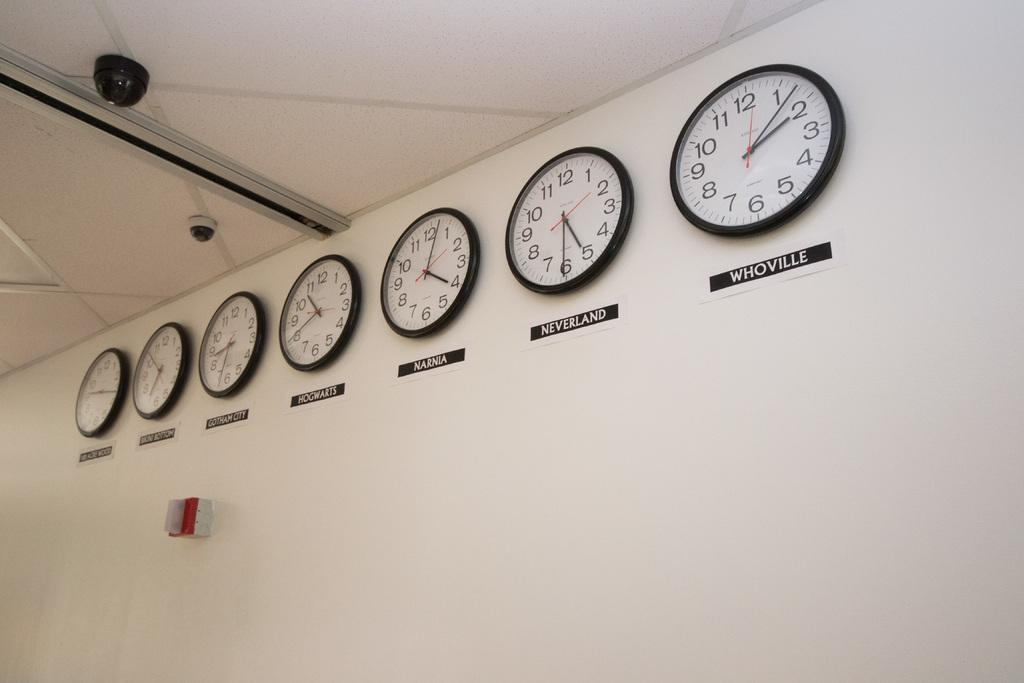<image>
Summarize the visual content of the image. A collection of mounted clocks displaying times of various fictional places. 